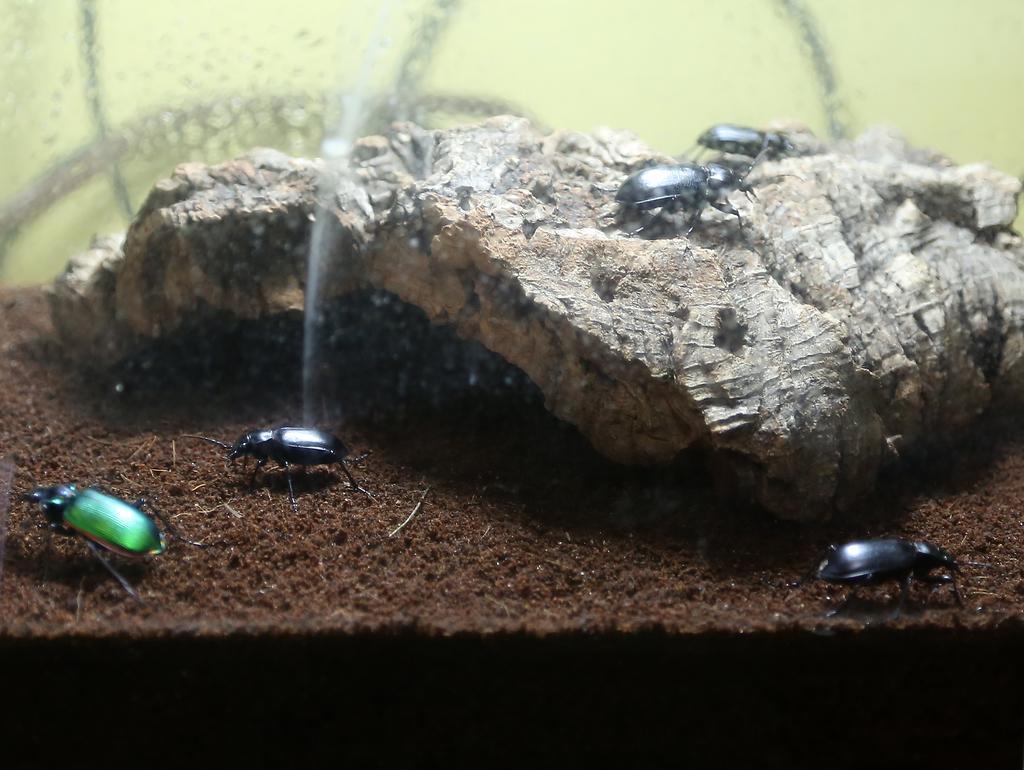Please provide a concise description of this image. In this image I can see the ground which is brown in color and few insects which are black and green in color on the ground. I can see a wooden object and two black colored insects on it. I can see the cream colored background. 